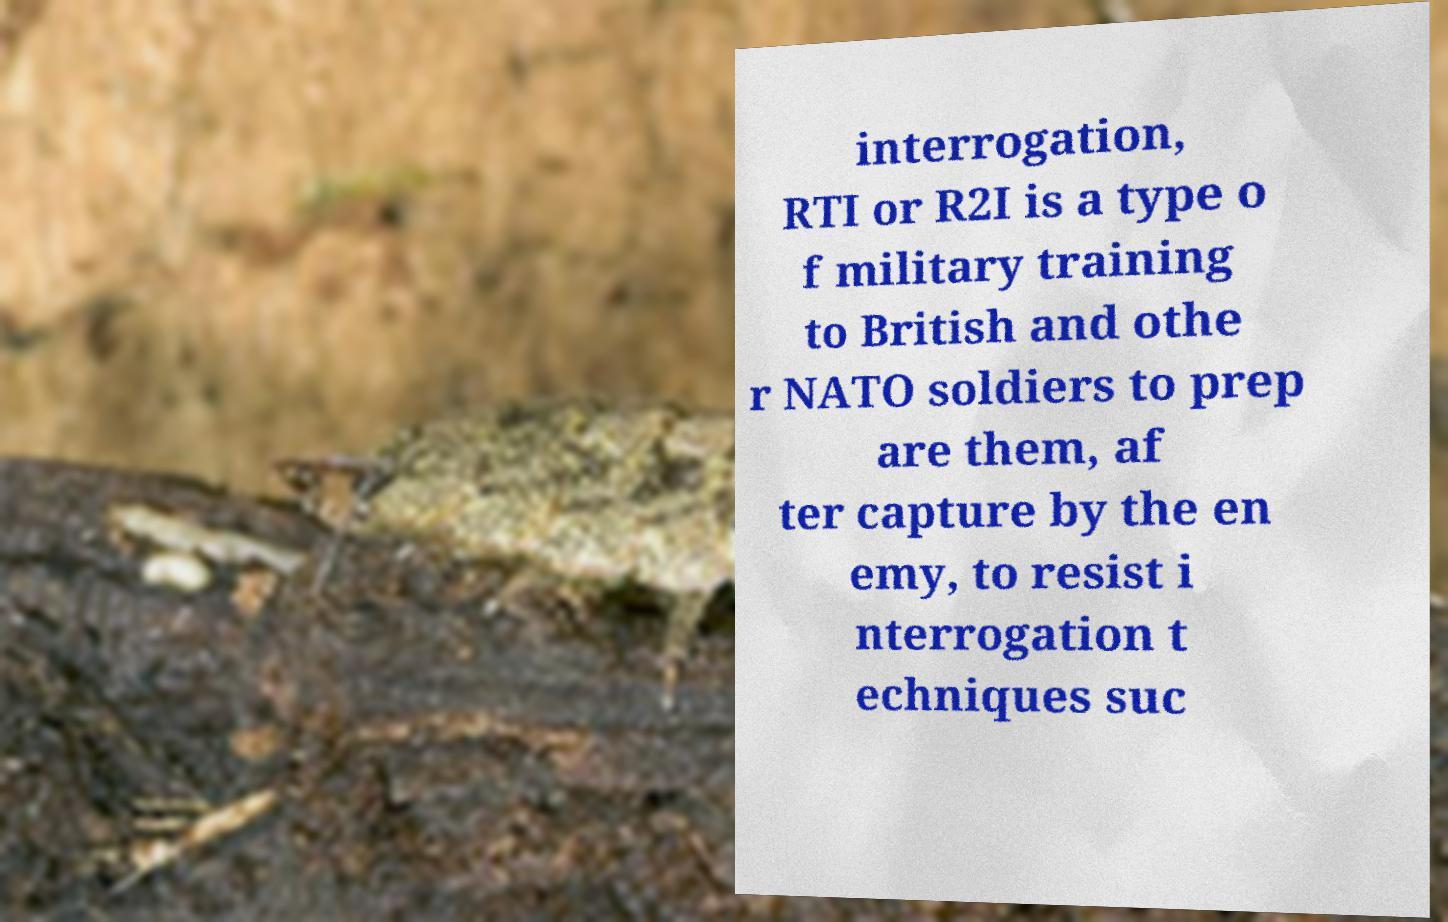Please identify and transcribe the text found in this image. interrogation, RTI or R2I is a type o f military training to British and othe r NATO soldiers to prep are them, af ter capture by the en emy, to resist i nterrogation t echniques suc 